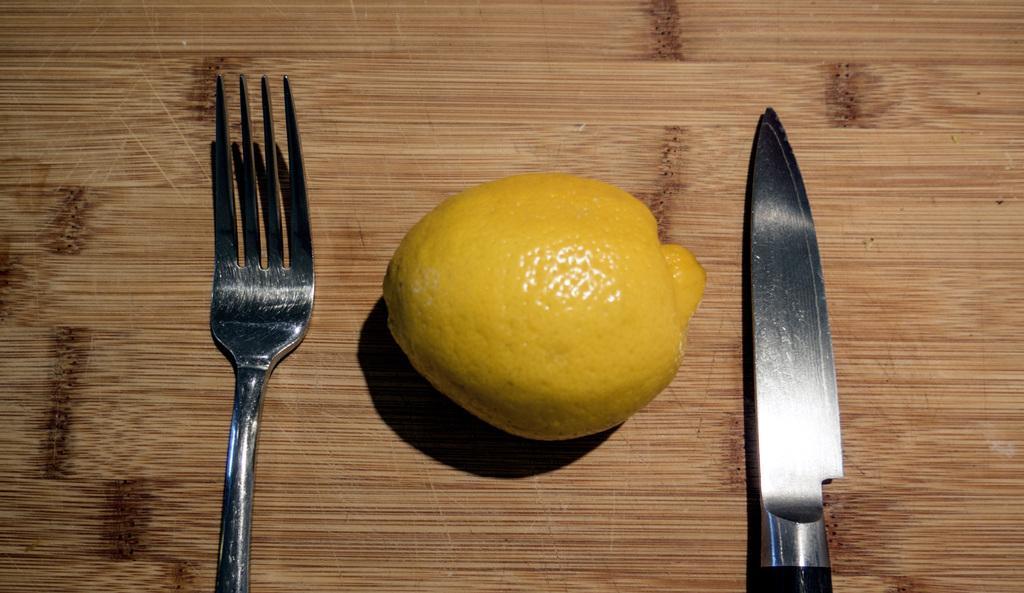Can you describe this image briefly? In this image we can see a fork, lemon and a knife which are placed on the table. 